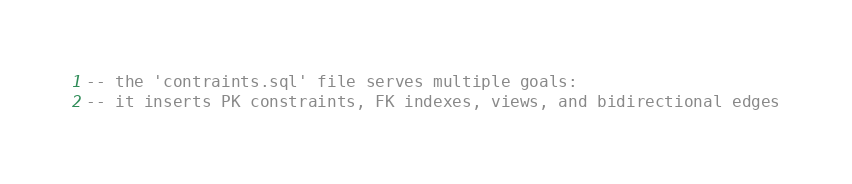Convert code to text. <code><loc_0><loc_0><loc_500><loc_500><_SQL_>-- the 'contraints.sql' file serves multiple goals:
-- it inserts PK constraints, FK indexes, views, and bidirectional edges
</code> 